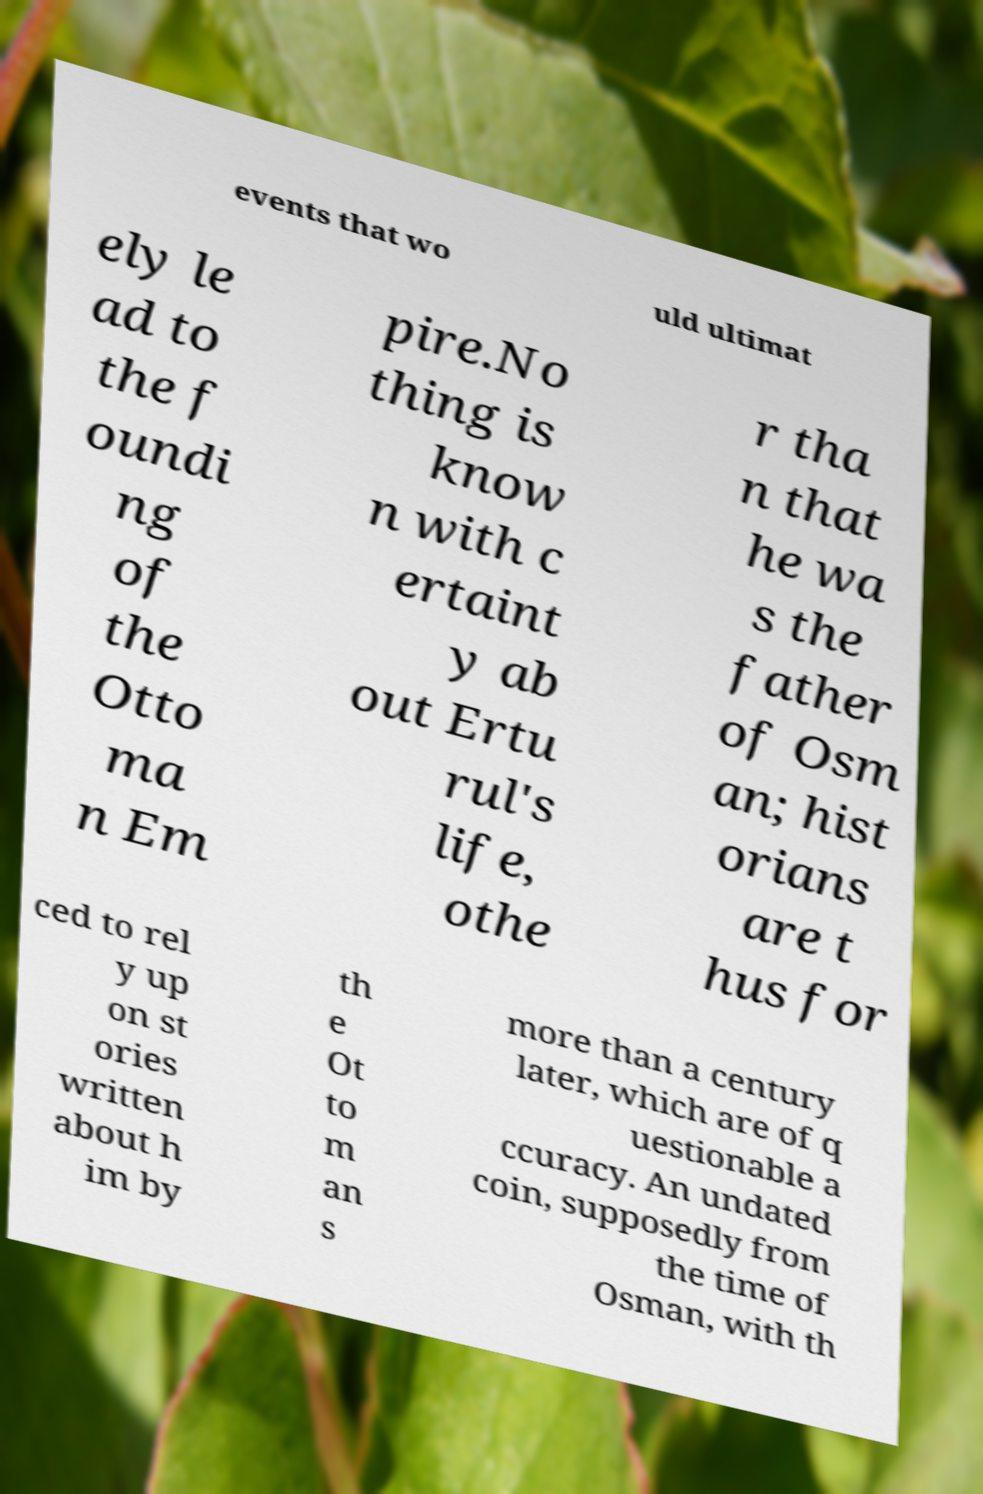Could you extract and type out the text from this image? events that wo uld ultimat ely le ad to the f oundi ng of the Otto ma n Em pire.No thing is know n with c ertaint y ab out Ertu rul's life, othe r tha n that he wa s the father of Osm an; hist orians are t hus for ced to rel y up on st ories written about h im by th e Ot to m an s more than a century later, which are of q uestionable a ccuracy. An undated coin, supposedly from the time of Osman, with th 